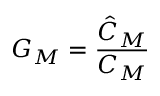<formula> <loc_0><loc_0><loc_500><loc_500>G _ { M } = \frac { \hat { C } _ { M } } { C _ { M } }</formula> 